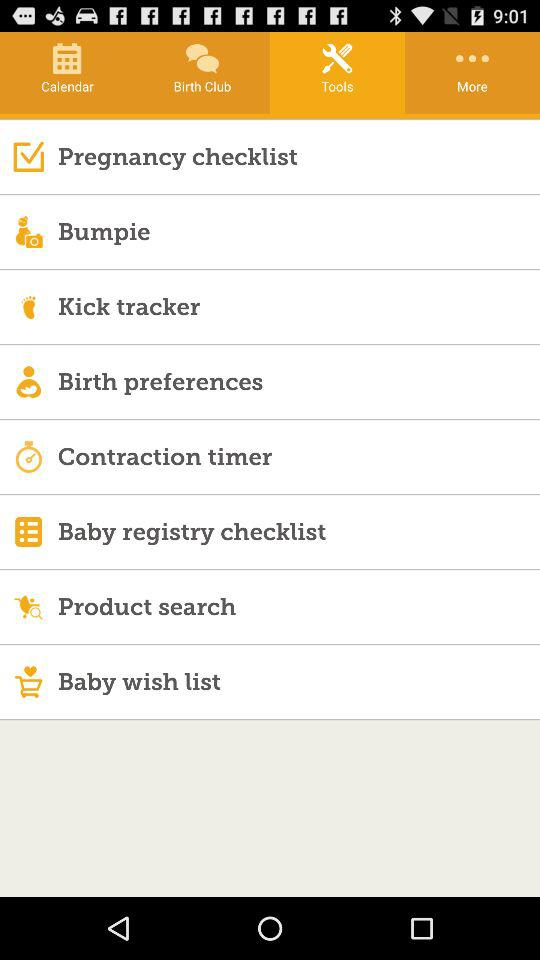Which tab is selected? The selected tab is "Tools". 